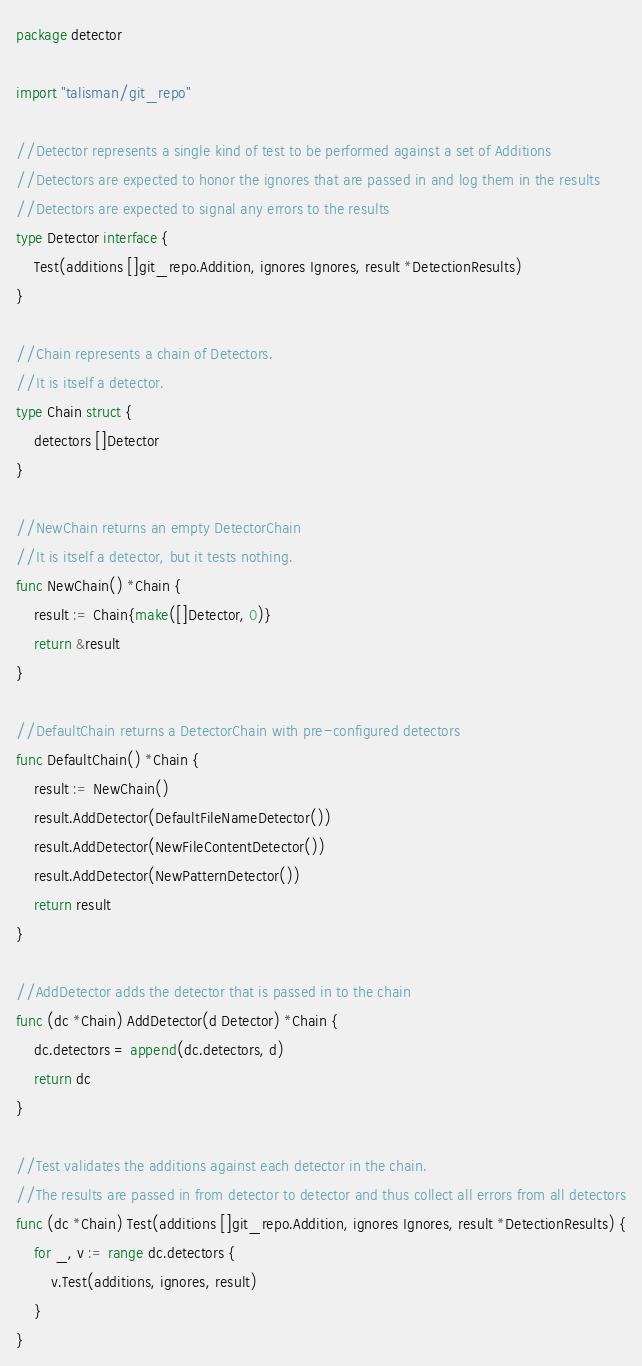<code> <loc_0><loc_0><loc_500><loc_500><_Go_>package detector

import "talisman/git_repo"

//Detector represents a single kind of test to be performed against a set of Additions
//Detectors are expected to honor the ignores that are passed in and log them in the results
//Detectors are expected to signal any errors to the results
type Detector interface {
	Test(additions []git_repo.Addition, ignores Ignores, result *DetectionResults)
}

//Chain represents a chain of Detectors.
//It is itself a detector.
type Chain struct {
	detectors []Detector
}

//NewChain returns an empty DetectorChain
//It is itself a detector, but it tests nothing.
func NewChain() *Chain {
	result := Chain{make([]Detector, 0)}
	return &result
}

//DefaultChain returns a DetectorChain with pre-configured detectors
func DefaultChain() *Chain {
	result := NewChain()
	result.AddDetector(DefaultFileNameDetector())
	result.AddDetector(NewFileContentDetector())
	result.AddDetector(NewPatternDetector())
	return result
}

//AddDetector adds the detector that is passed in to the chain
func (dc *Chain) AddDetector(d Detector) *Chain {
	dc.detectors = append(dc.detectors, d)
	return dc
}

//Test validates the additions against each detector in the chain.
//The results are passed in from detector to detector and thus collect all errors from all detectors
func (dc *Chain) Test(additions []git_repo.Addition, ignores Ignores, result *DetectionResults) {
	for _, v := range dc.detectors {
		v.Test(additions, ignores, result)
	}
}
</code> 